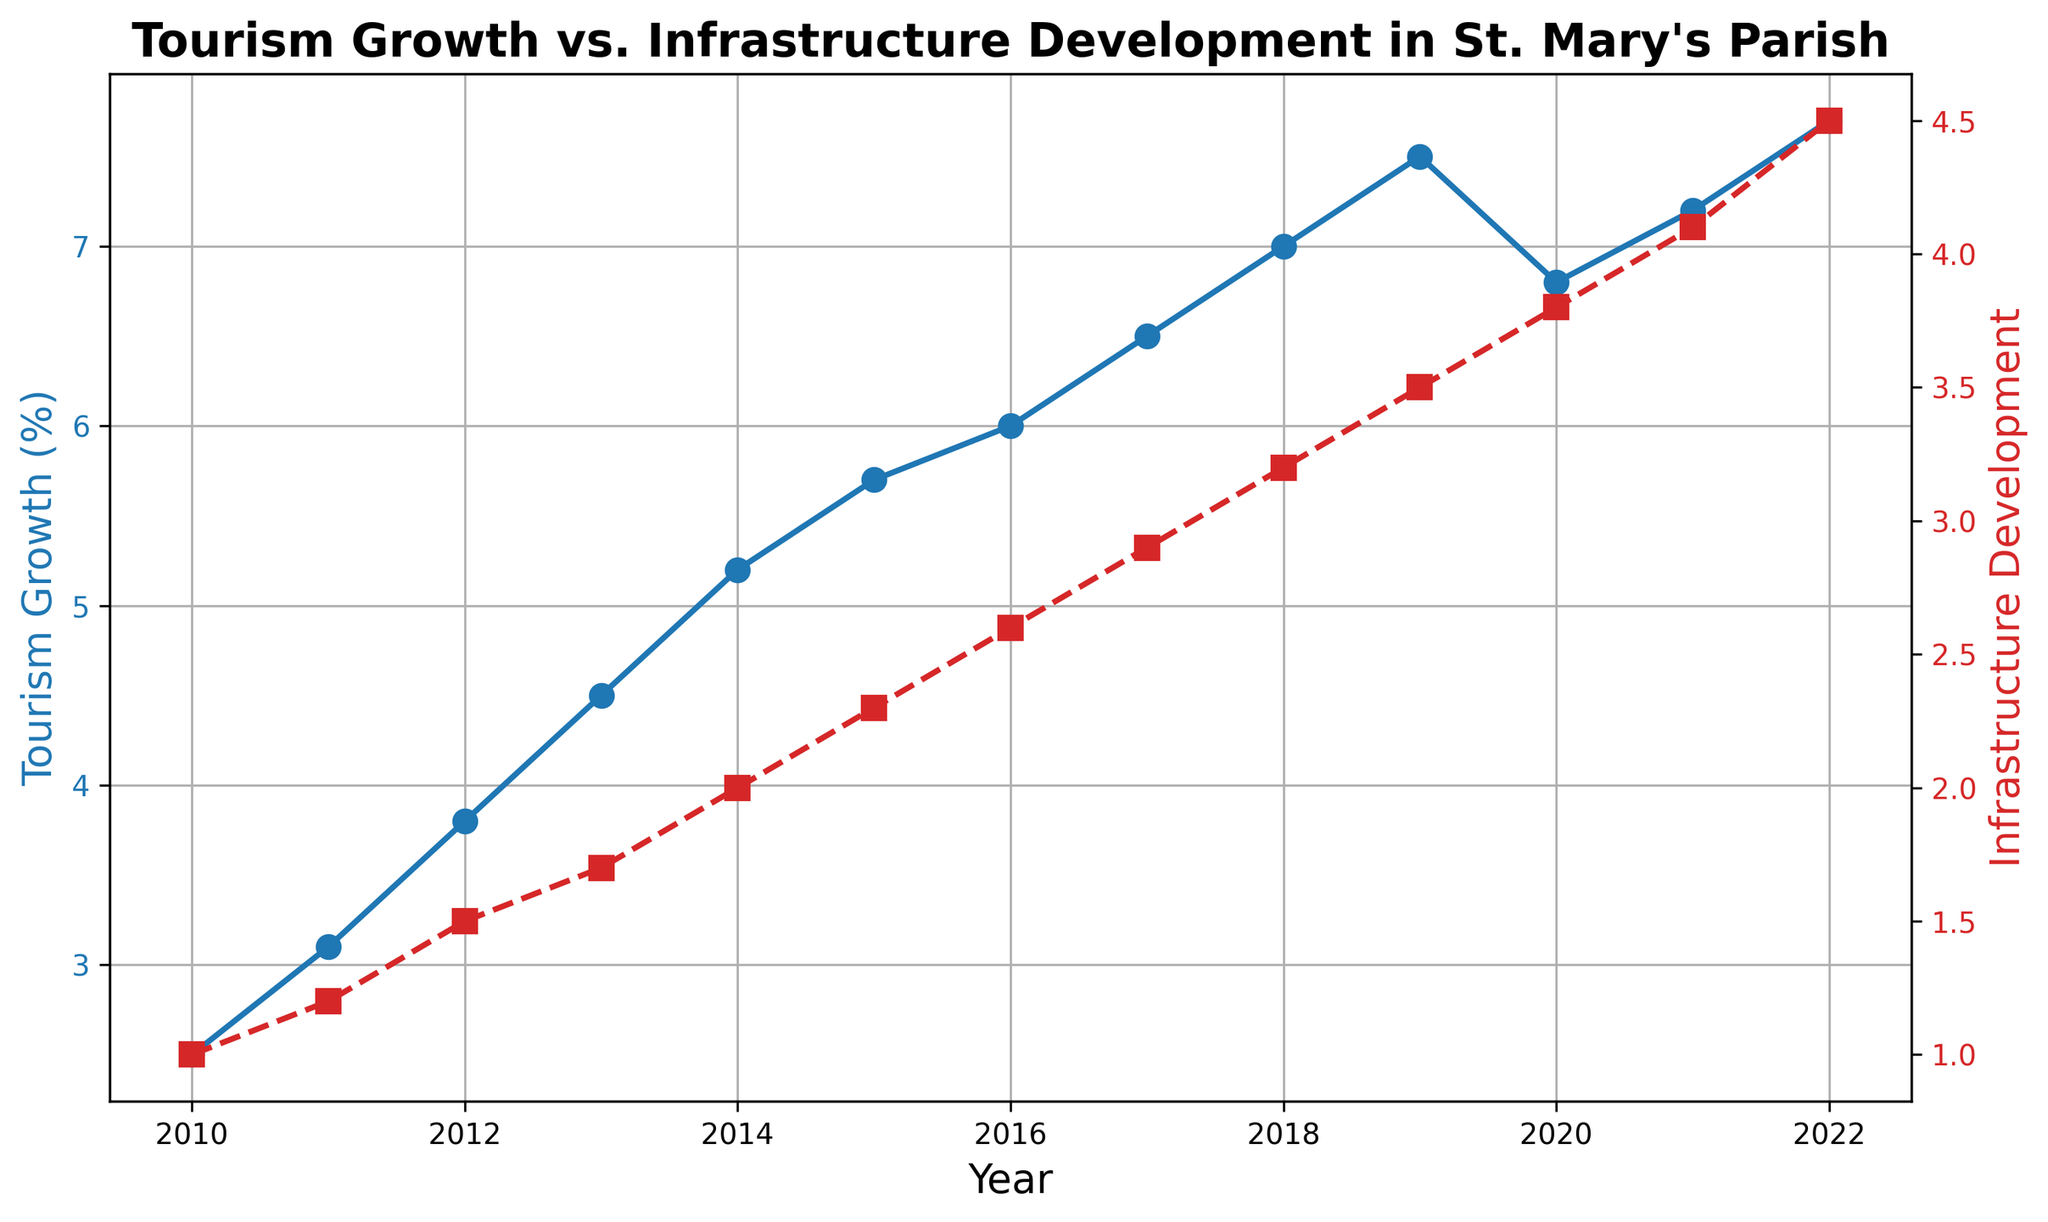What is the slope of Tourism Growth trend from 2010 to 2022? To find the slope of the Tourism Growth trend, calculate the change in Tourism Growth and divide it by the change in years: (7.7 - 2.5) / (2022 - 2010)
Answer: 0.425 In which year did Tourism Growth and Infrastructure Development show the highest increase compared to the previous year? Compare the differences year-over-year for both metrics: Tourism Growth shows its highest increase from 2018 to 2019 (0.5) and Infrastructure Development shows its highest increase from 2021 to 2022 (0.4).
Answer: 2018 for Tourism, 2021 for Infrastructure Which data point shows the largest gap between Tourism Growth and Infrastructure Development? Calculate the differences for each year and find the maximum difference: 2010 has a difference of 1.5 (2.5 - 1), which is the largest gap.
Answer: 2010 During which period did Tourism Growth consistently increase but Infrastructure Development remained the same? Observe the plot to identify periods where Tourism Growth rises but Infrastructure Development does not change: from 2010 to 2011, and from 2011 to 2012, Infrastructure Development increases, so no such period exists.
Answer: None How did Tourism Growth and Infrastructure Development change from 2020 to 2021? For Tourism Growth: 2021 value (7.2) - 2020 value (6.8) = 0.4 increase; For Infrastructure Development: 2021 value (4.1) - 2020 value (3.8) = 0.3 increase
Answer: Both increased, Tourism by 0.4, Infrastructure by 0.3 In which year did Tourism Growth dip compared to the previous year and what was the corresponding change in Infrastructure Development? Find the year where Tourism Growth decreased compared to its previous year: from 2019 (7.5) to 2020 (6.8) it decreased. The Infrastructure Development corresponding change was from 3.5 to 3.8, which is an increase.
Answer: 2020, Infrastructure increased by 0.3 What is the average Tourism Growth from 2010 to 2022? Sum Tourism Growth values from 2010 to 2022 and divide by the number of years (13): (2.5 + 3.1 + 3.8 + 4.5 + 5.2 + 5.7 + 6.0 + 6.5 + 7.0 + 7.5 + 6.8 + 7.2 + 7.7) / 13 = 5.5538
Answer: 5.55 Between which years did Infrastructure Development see its steepest increase? Determine the year-over-year differences and find the maximum increase: from 2021 (4.1) to 2022 (4.5) has the largest increase of 0.4
Answer: 2021 to 2022 What is the color used to represent Infrastructure Development on the plot? The plot uses the secondary y-axis line color to represent Infrastructure Development, which is described as 'red'.
Answer: Red What is the trend of Tourism Growth from 2010 to 2022 and does it show any obvious anomalies or patterns? Observe the plot: Tourism Growth has been generally increasing, with a slight dip in 2020, followed by a recovery.
Answer: Increasing with a dip in 2020 